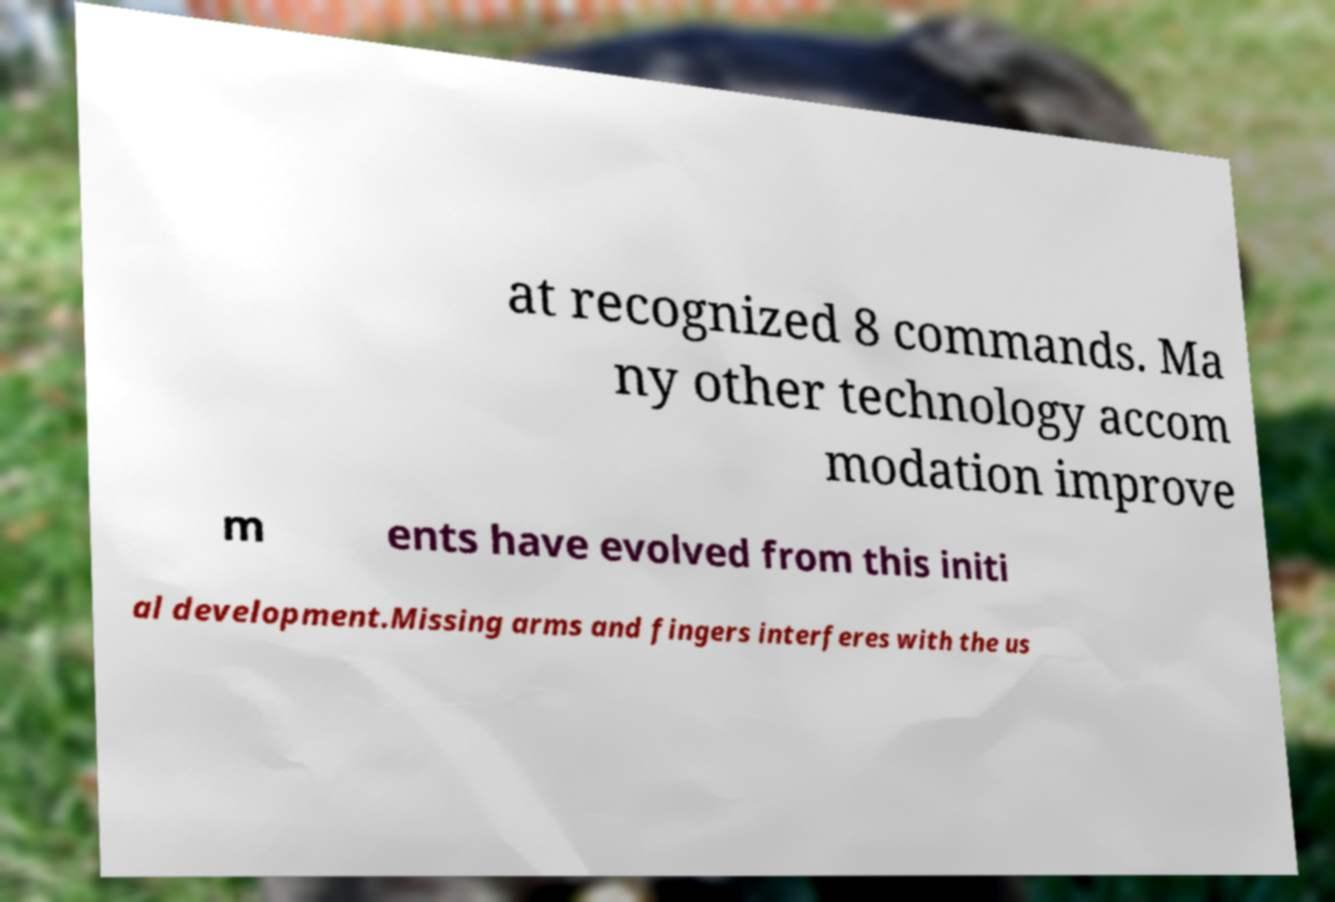Please identify and transcribe the text found in this image. at recognized 8 commands. Ma ny other technology accom modation improve m ents have evolved from this initi al development.Missing arms and fingers interferes with the us 